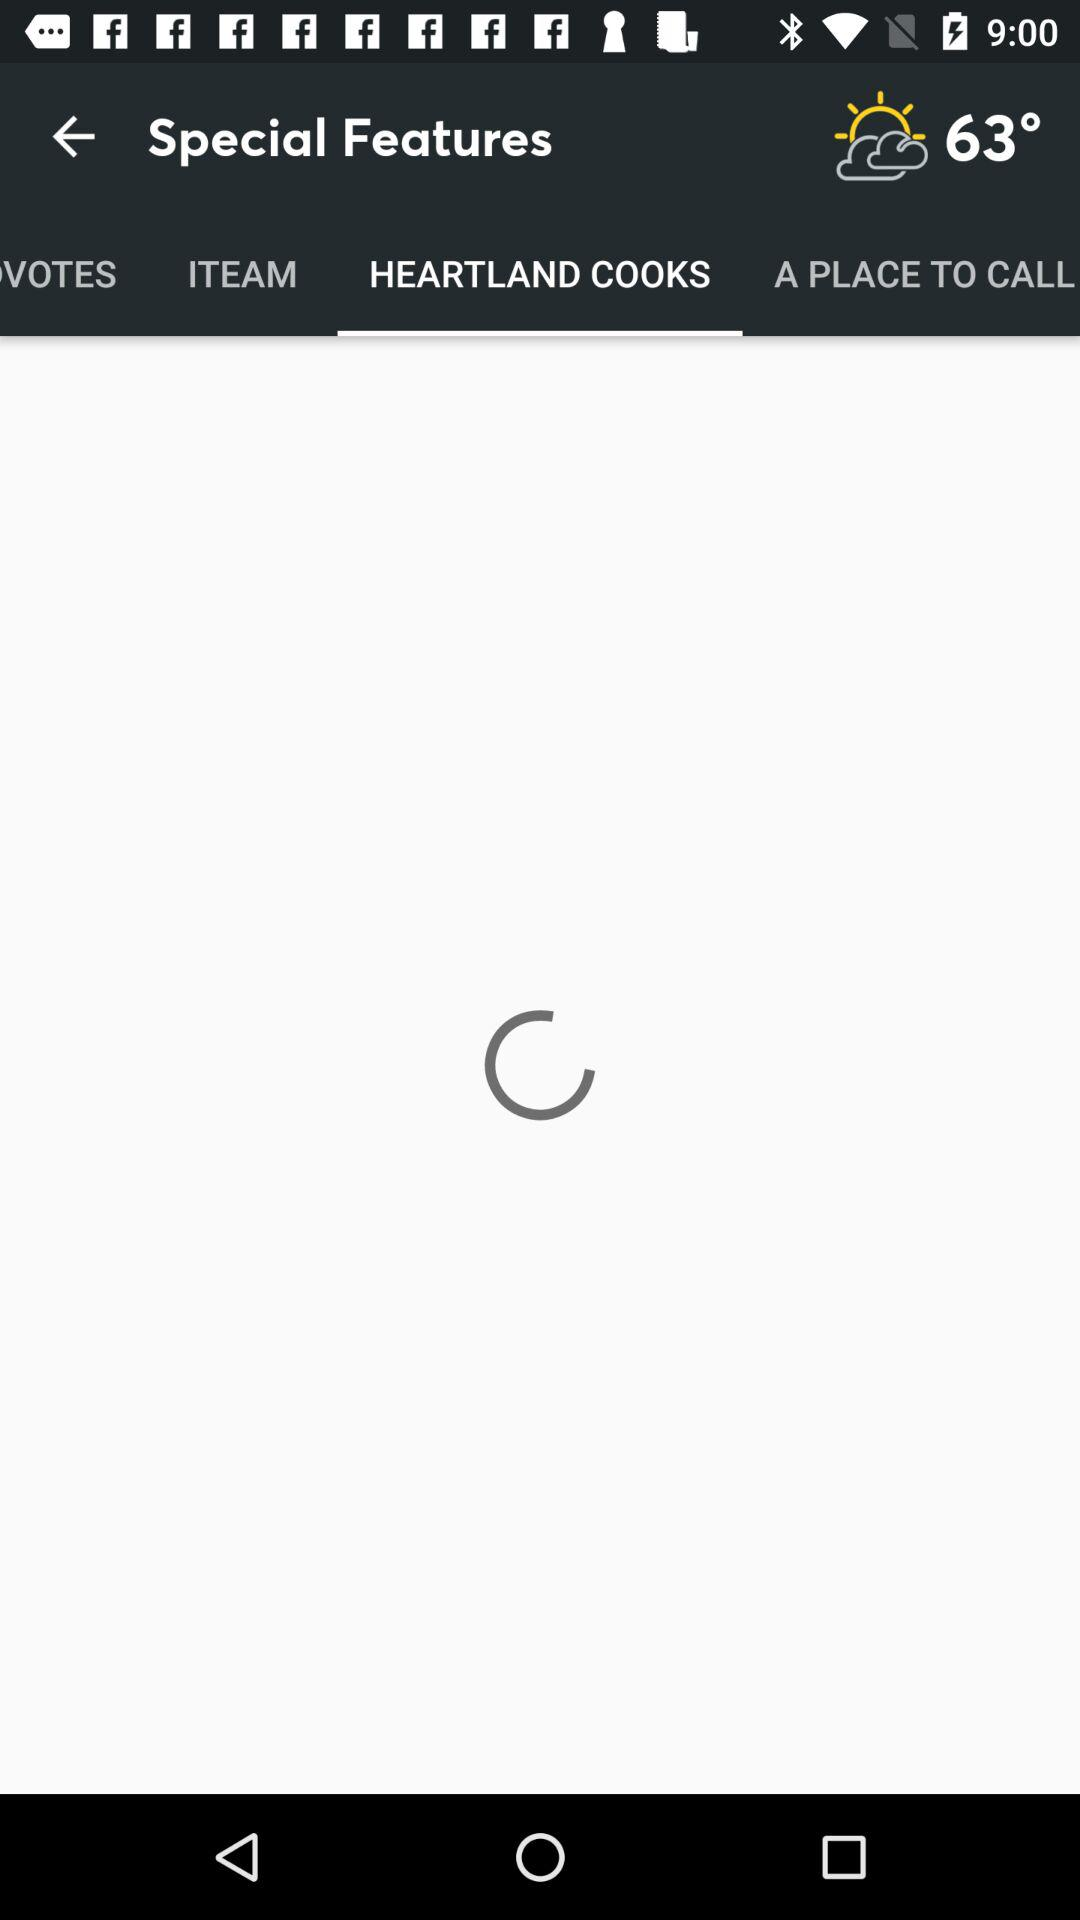What is the temperature showing in the application? The temperature showing in the application is 63°. 